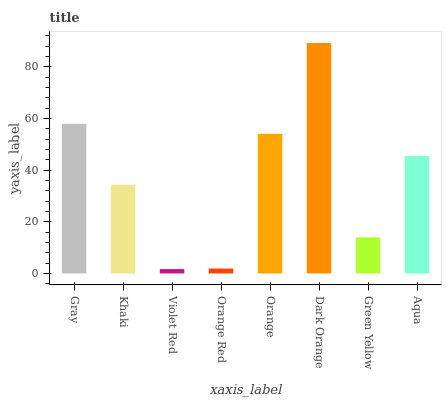Is Violet Red the minimum?
Answer yes or no. Yes. Is Dark Orange the maximum?
Answer yes or no. Yes. Is Khaki the minimum?
Answer yes or no. No. Is Khaki the maximum?
Answer yes or no. No. Is Gray greater than Khaki?
Answer yes or no. Yes. Is Khaki less than Gray?
Answer yes or no. Yes. Is Khaki greater than Gray?
Answer yes or no. No. Is Gray less than Khaki?
Answer yes or no. No. Is Aqua the high median?
Answer yes or no. Yes. Is Khaki the low median?
Answer yes or no. Yes. Is Green Yellow the high median?
Answer yes or no. No. Is Violet Red the low median?
Answer yes or no. No. 